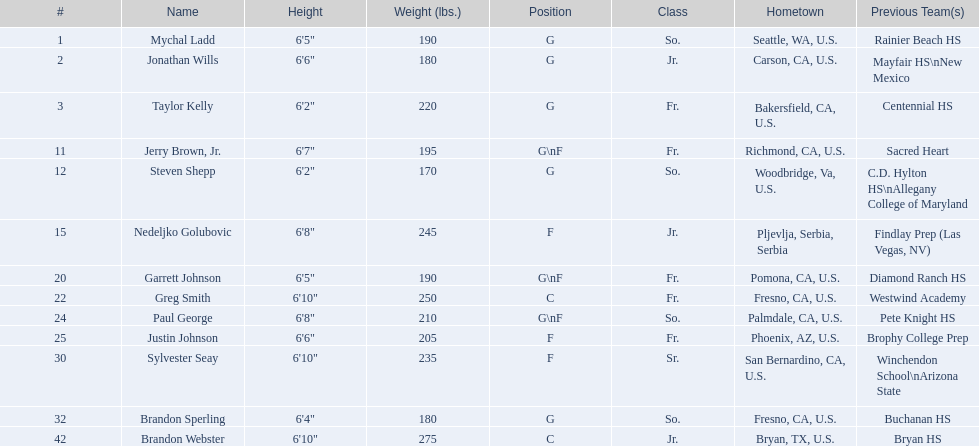What are the birthplaces of all the players? So., Jr., Fr., Fr., So., Jr., Fr., Fr., So., Fr., Sr., So., Jr. Can you identify the one from serbia? Nedeljko Golubovic. Can you identify the forwards in the team? Nedeljko Golubovic, Paul George, Justin Johnson, Sylvester Seay. How tall are they? Nedeljko Golubovic, 6'8", Paul George, 6'8", Justin Johnson, 6'6", Sylvester Seay, 6'10". Who among them has the shortest height? Justin Johnson. 